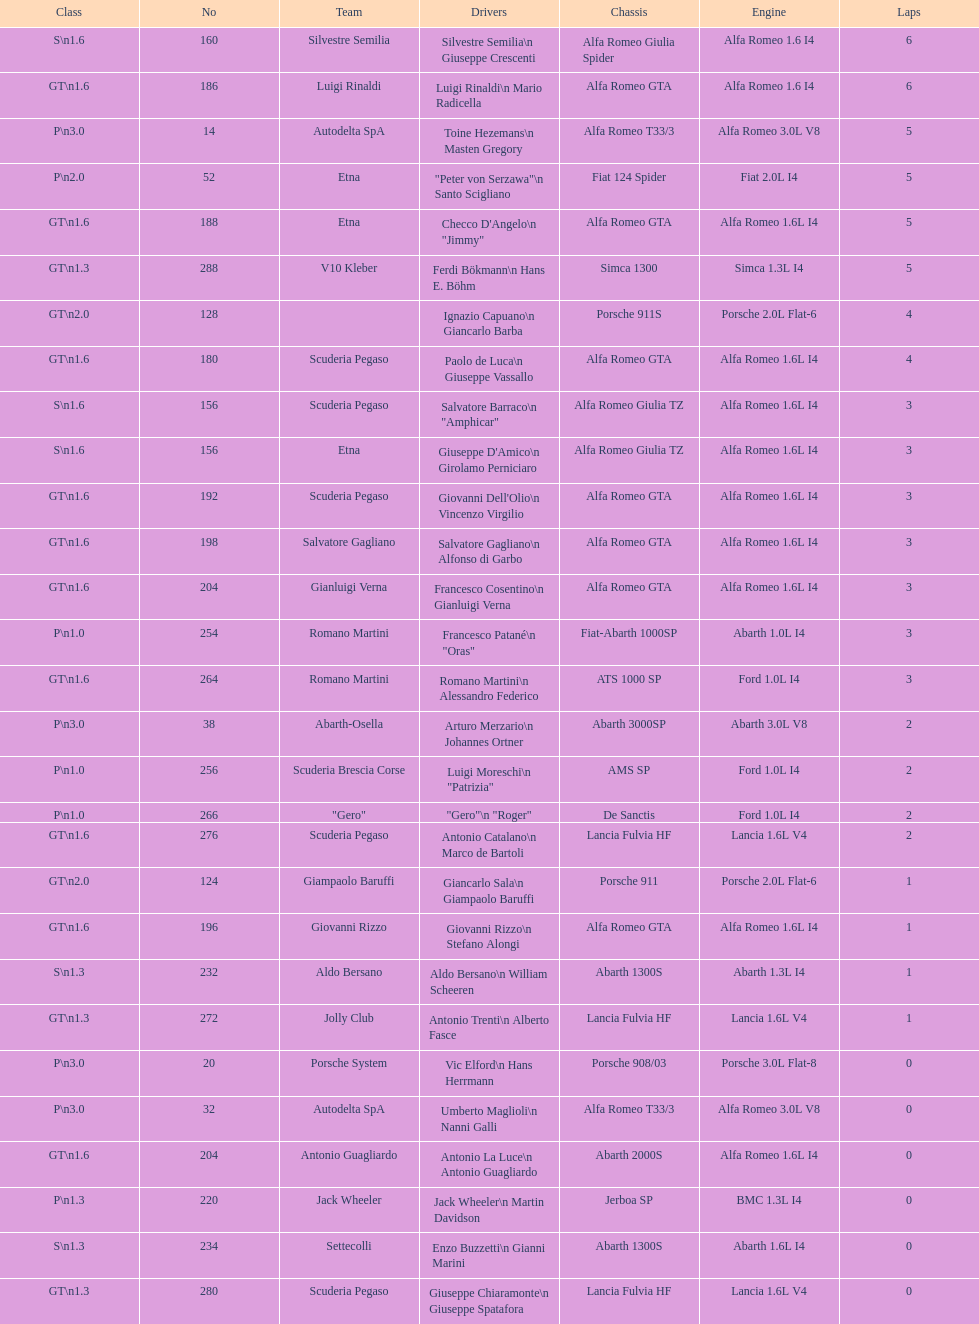Which framework is in the midst of simca 1300 and alfa romeo gta? Porsche 911S. Write the full table. {'header': ['Class', 'No', 'Team', 'Drivers', 'Chassis', 'Engine', 'Laps'], 'rows': [['S\\n1.6', '160', 'Silvestre Semilia', 'Silvestre Semilia\\n Giuseppe Crescenti', 'Alfa Romeo Giulia Spider', 'Alfa Romeo 1.6 I4', '6'], ['GT\\n1.6', '186', 'Luigi Rinaldi', 'Luigi Rinaldi\\n Mario Radicella', 'Alfa Romeo GTA', 'Alfa Romeo 1.6 I4', '6'], ['P\\n3.0', '14', 'Autodelta SpA', 'Toine Hezemans\\n Masten Gregory', 'Alfa Romeo T33/3', 'Alfa Romeo 3.0L V8', '5'], ['P\\n2.0', '52', 'Etna', '"Peter von Serzawa"\\n Santo Scigliano', 'Fiat 124 Spider', 'Fiat 2.0L I4', '5'], ['GT\\n1.6', '188', 'Etna', 'Checco D\'Angelo\\n "Jimmy"', 'Alfa Romeo GTA', 'Alfa Romeo 1.6L I4', '5'], ['GT\\n1.3', '288', 'V10 Kleber', 'Ferdi Bökmann\\n Hans E. Böhm', 'Simca 1300', 'Simca 1.3L I4', '5'], ['GT\\n2.0', '128', '', 'Ignazio Capuano\\n Giancarlo Barba', 'Porsche 911S', 'Porsche 2.0L Flat-6', '4'], ['GT\\n1.6', '180', 'Scuderia Pegaso', 'Paolo de Luca\\n Giuseppe Vassallo', 'Alfa Romeo GTA', 'Alfa Romeo 1.6L I4', '4'], ['S\\n1.6', '156', 'Scuderia Pegaso', 'Salvatore Barraco\\n "Amphicar"', 'Alfa Romeo Giulia TZ', 'Alfa Romeo 1.6L I4', '3'], ['S\\n1.6', '156', 'Etna', "Giuseppe D'Amico\\n Girolamo Perniciaro", 'Alfa Romeo Giulia TZ', 'Alfa Romeo 1.6L I4', '3'], ['GT\\n1.6', '192', 'Scuderia Pegaso', "Giovanni Dell'Olio\\n Vincenzo Virgilio", 'Alfa Romeo GTA', 'Alfa Romeo 1.6L I4', '3'], ['GT\\n1.6', '198', 'Salvatore Gagliano', 'Salvatore Gagliano\\n Alfonso di Garbo', 'Alfa Romeo GTA', 'Alfa Romeo 1.6L I4', '3'], ['GT\\n1.6', '204', 'Gianluigi Verna', 'Francesco Cosentino\\n Gianluigi Verna', 'Alfa Romeo GTA', 'Alfa Romeo 1.6L I4', '3'], ['P\\n1.0', '254', 'Romano Martini', 'Francesco Patané\\n "Oras"', 'Fiat-Abarth 1000SP', 'Abarth 1.0L I4', '3'], ['GT\\n1.6', '264', 'Romano Martini', 'Romano Martini\\n Alessandro Federico', 'ATS 1000 SP', 'Ford 1.0L I4', '3'], ['P\\n3.0', '38', 'Abarth-Osella', 'Arturo Merzario\\n Johannes Ortner', 'Abarth 3000SP', 'Abarth 3.0L V8', '2'], ['P\\n1.0', '256', 'Scuderia Brescia Corse', 'Luigi Moreschi\\n "Patrizia"', 'AMS SP', 'Ford 1.0L I4', '2'], ['P\\n1.0', '266', '"Gero"', '"Gero"\\n "Roger"', 'De Sanctis', 'Ford 1.0L I4', '2'], ['GT\\n1.6', '276', 'Scuderia Pegaso', 'Antonio Catalano\\n Marco de Bartoli', 'Lancia Fulvia HF', 'Lancia 1.6L V4', '2'], ['GT\\n2.0', '124', 'Giampaolo Baruffi', 'Giancarlo Sala\\n Giampaolo Baruffi', 'Porsche 911', 'Porsche 2.0L Flat-6', '1'], ['GT\\n1.6', '196', 'Giovanni Rizzo', 'Giovanni Rizzo\\n Stefano Alongi', 'Alfa Romeo GTA', 'Alfa Romeo 1.6L I4', '1'], ['S\\n1.3', '232', 'Aldo Bersano', 'Aldo Bersano\\n William Scheeren', 'Abarth 1300S', 'Abarth 1.3L I4', '1'], ['GT\\n1.3', '272', 'Jolly Club', 'Antonio Trenti\\n Alberto Fasce', 'Lancia Fulvia HF', 'Lancia 1.6L V4', '1'], ['P\\n3.0', '20', 'Porsche System', 'Vic Elford\\n Hans Herrmann', 'Porsche 908/03', 'Porsche 3.0L Flat-8', '0'], ['P\\n3.0', '32', 'Autodelta SpA', 'Umberto Maglioli\\n Nanni Galli', 'Alfa Romeo T33/3', 'Alfa Romeo 3.0L V8', '0'], ['GT\\n1.6', '204', 'Antonio Guagliardo', 'Antonio La Luce\\n Antonio Guagliardo', 'Abarth 2000S', 'Alfa Romeo 1.6L I4', '0'], ['P\\n1.3', '220', 'Jack Wheeler', 'Jack Wheeler\\n Martin Davidson', 'Jerboa SP', 'BMC 1.3L I4', '0'], ['S\\n1.3', '234', 'Settecolli', 'Enzo Buzzetti\\n Gianni Marini', 'Abarth 1300S', 'Abarth 1.6L I4', '0'], ['GT\\n1.3', '280', 'Scuderia Pegaso', 'Giuseppe Chiaramonte\\n Giuseppe Spatafora', 'Lancia Fulvia HF', 'Lancia 1.6L V4', '0']]} 